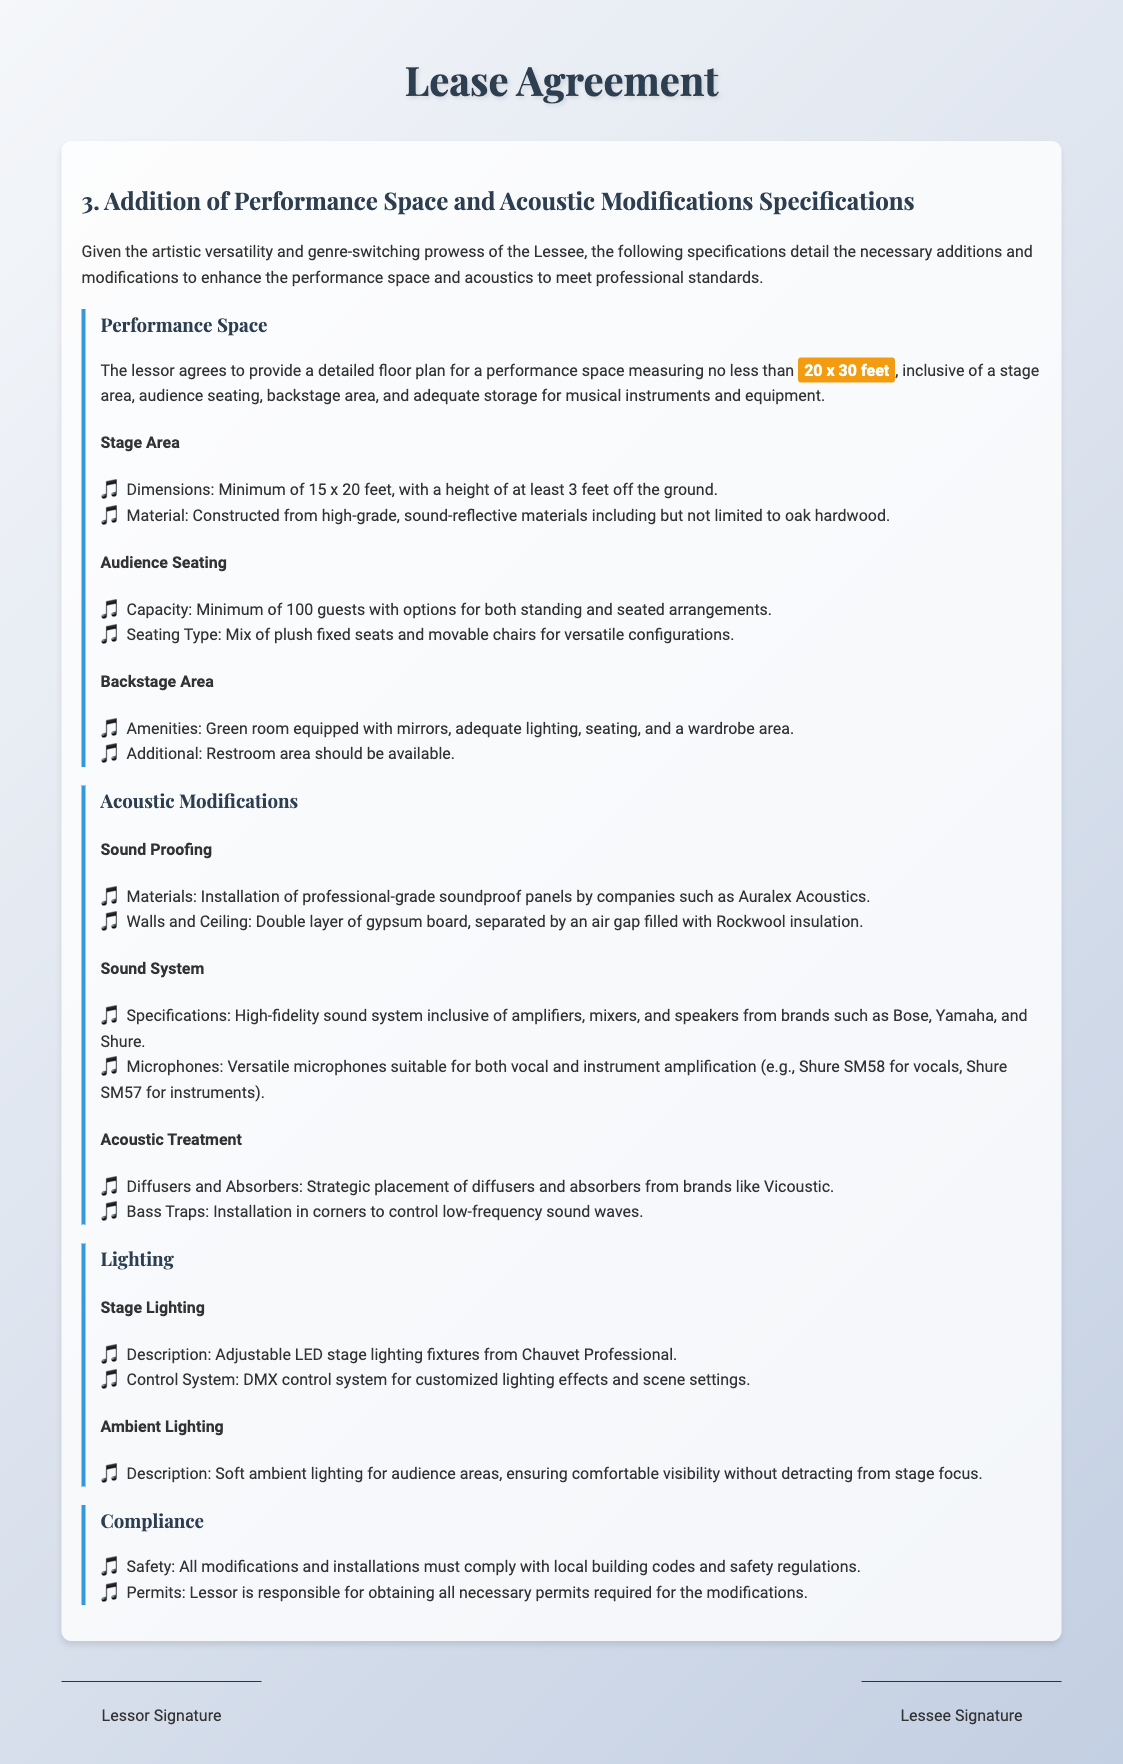What are the minimum dimensions of the performance space? The document specifies that the performance space must measure no less than 20 x 30 feet.
Answer: 20 x 30 feet What is the capacity of the audience seating? The audience seating must have a minimum capacity of 100 guests.
Answer: 100 guests What is the height of the stage area? The height of the stage area must be at least 3 feet off the ground.
Answer: 3 feet Which brand is mentioned for installing soundproof panels? The document mentions Auralex Acoustics for soundproofing materials.
Answer: Auralex Acoustics What type of control system is indicated for stage lighting? The stage lighting control system specified is a DMX control system.
Answer: DMX control system What is included in the backstage area amenities? The backstage area amenities include a green room equipped with mirrors.
Answer: Green room equipped with mirrors What must be obtained by the lessor for modifications? The lessor is responsible for obtaining all necessary permits for the modifications.
Answer: Necessary permits What type of seating is mentioned for the audience? The seating type for the audience is a mix of plush fixed seats and movable chairs.
Answer: Mix of plush fixed seats and movable chairs What is required for compliance regarding modifications? All modifications must comply with local building codes and safety regulations.
Answer: Local building codes and safety regulations 